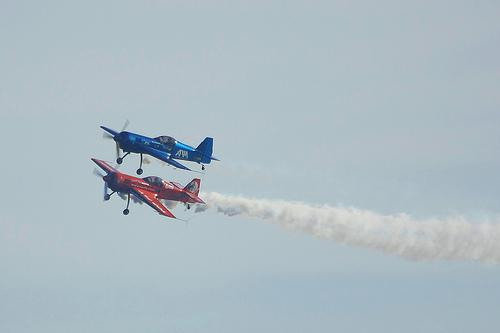Question: what is in the background of the photo?
Choices:
A. Trees.
B. Mountains.
C. Blue skies.
D. Clouds.
Answer with the letter. Answer: C Question: why are the planes in the sky?
Choices:
A. Air show.
B. Military escort.
C. Waiting to land.
D. They are flying.
Answer with the letter. Answer: D Question: who is flying the planes?
Choices:
A. Pilots.
B. War veterans.
C. Flying students.
D. Men.
Answer with the letter. Answer: A 